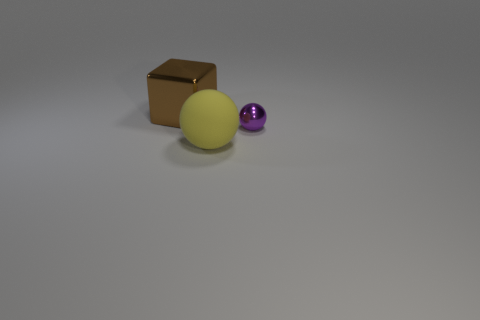Add 2 big cubes. How many objects exist? 5 Subtract all blocks. How many objects are left? 2 Add 1 small purple objects. How many small purple objects exist? 2 Subtract 0 brown cylinders. How many objects are left? 3 Subtract all big brown cylinders. Subtract all big shiny things. How many objects are left? 2 Add 2 purple spheres. How many purple spheres are left? 3 